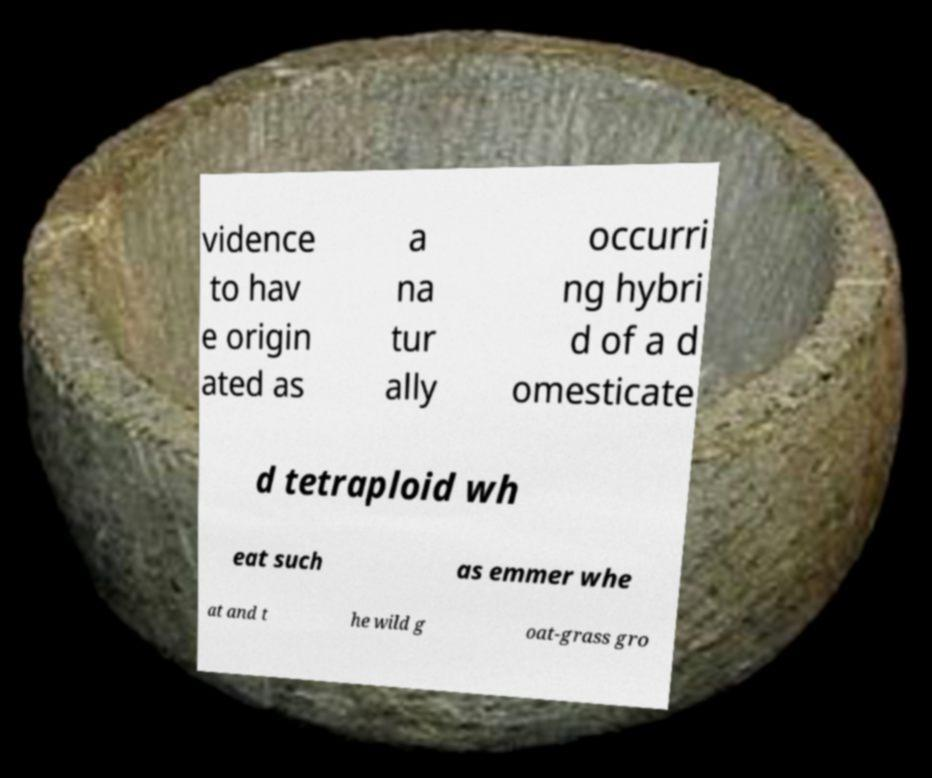For documentation purposes, I need the text within this image transcribed. Could you provide that? vidence to hav e origin ated as a na tur ally occurri ng hybri d of a d omesticate d tetraploid wh eat such as emmer whe at and t he wild g oat-grass gro 